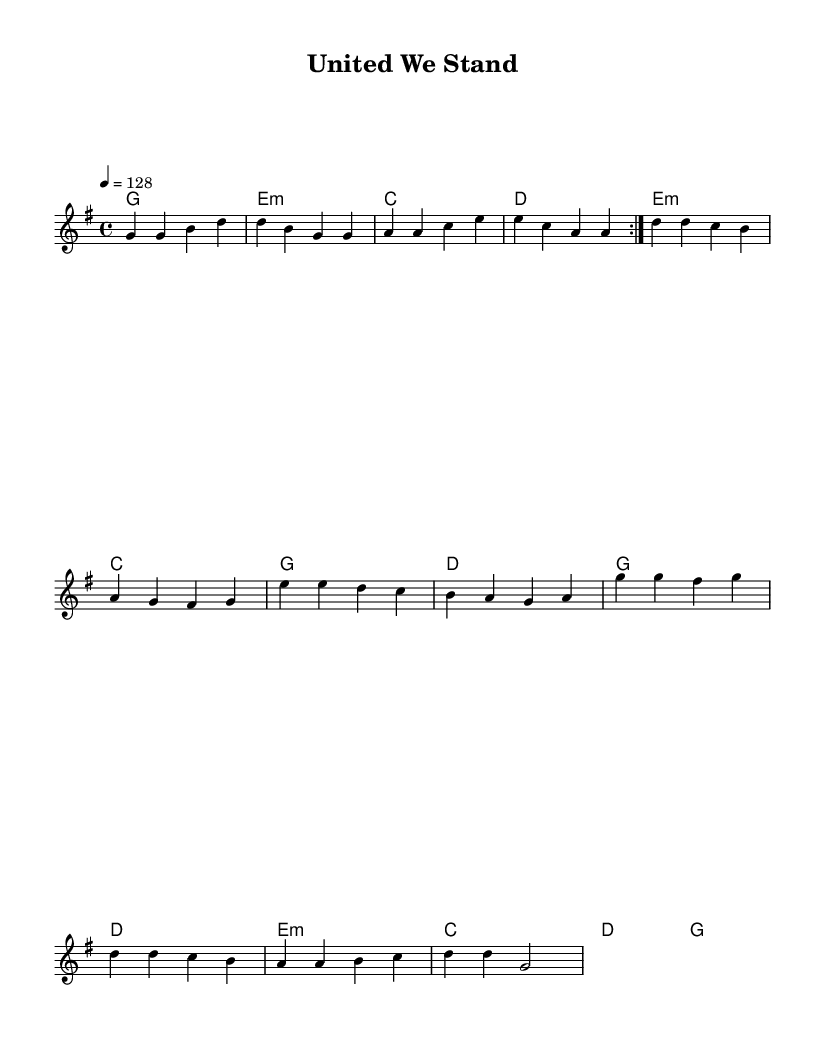What is the key signature of this music? The key signature is G major, which has one sharp (F#).
Answer: G major What is the time signature of this music? The time signature is 4/4, indicating four beats in each measure.
Answer: 4/4 What is the tempo marking indicated in the score? The tempo marking is 128 beats per minute, noted as "4 = 128".
Answer: 128 How many measures are repeated in the melody section? The melody contains a repeated section denoted by "volta 2", meaning the first section is played twice.
Answer: 2 What type of chord is played in the second measure? The second measure contains an E minor chord, noted as "e:m".
Answer: E minor How does the melody change in the second half of the piece? In the second half, the melody descends in pitch from the higher notes of the first half, indicating a variation in melodic contour for emotional effect.
Answer: Descends What is the last note of the melody in the last measure? The last note of the melody is a G note, which indicates the closing tonal center.
Answer: G 